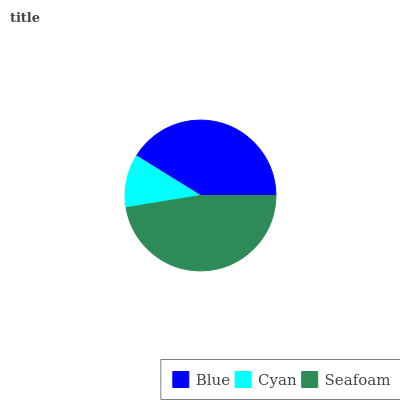Is Cyan the minimum?
Answer yes or no. Yes. Is Seafoam the maximum?
Answer yes or no. Yes. Is Seafoam the minimum?
Answer yes or no. No. Is Cyan the maximum?
Answer yes or no. No. Is Seafoam greater than Cyan?
Answer yes or no. Yes. Is Cyan less than Seafoam?
Answer yes or no. Yes. Is Cyan greater than Seafoam?
Answer yes or no. No. Is Seafoam less than Cyan?
Answer yes or no. No. Is Blue the high median?
Answer yes or no. Yes. Is Blue the low median?
Answer yes or no. Yes. Is Cyan the high median?
Answer yes or no. No. Is Seafoam the low median?
Answer yes or no. No. 